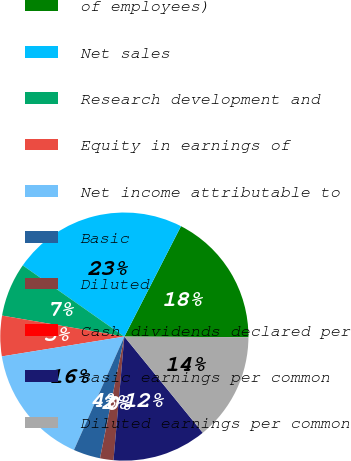Convert chart to OTSL. <chart><loc_0><loc_0><loc_500><loc_500><pie_chart><fcel>of employees)<fcel>Net sales<fcel>Research development and<fcel>Equity in earnings of<fcel>Net income attributable to<fcel>Basic<fcel>Diluted<fcel>Cash dividends declared per<fcel>Basic earnings per common<fcel>Diluted earnings per common<nl><fcel>17.54%<fcel>22.81%<fcel>7.02%<fcel>5.26%<fcel>15.79%<fcel>3.51%<fcel>1.75%<fcel>0.0%<fcel>12.28%<fcel>14.03%<nl></chart> 